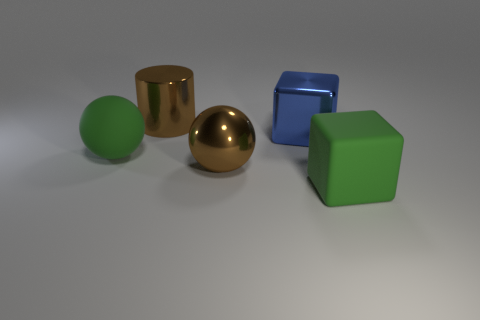What is the material of the ball that is the same color as the rubber cube?
Offer a terse response. Rubber. Is there a big sphere of the same color as the metallic cylinder?
Offer a terse response. Yes. Is there a large cylinder made of the same material as the green ball?
Provide a short and direct response. No. Is there a big brown metal object that is left of the big brown thing left of the large brown thing in front of the blue object?
Ensure brevity in your answer.  No. What number of other objects are there of the same shape as the large blue shiny thing?
Keep it short and to the point. 1. What is the color of the big ball that is to the left of the brown object behind the green object to the left of the large green matte cube?
Provide a succinct answer. Green. How many big brown things are there?
Give a very brief answer. 2. What number of big objects are gray things or brown cylinders?
Offer a very short reply. 1. There is a blue shiny thing that is the same size as the green matte cube; what is its shape?
Your answer should be very brief. Cube. The green object behind the rubber object in front of the green rubber ball is made of what material?
Offer a very short reply. Rubber. 